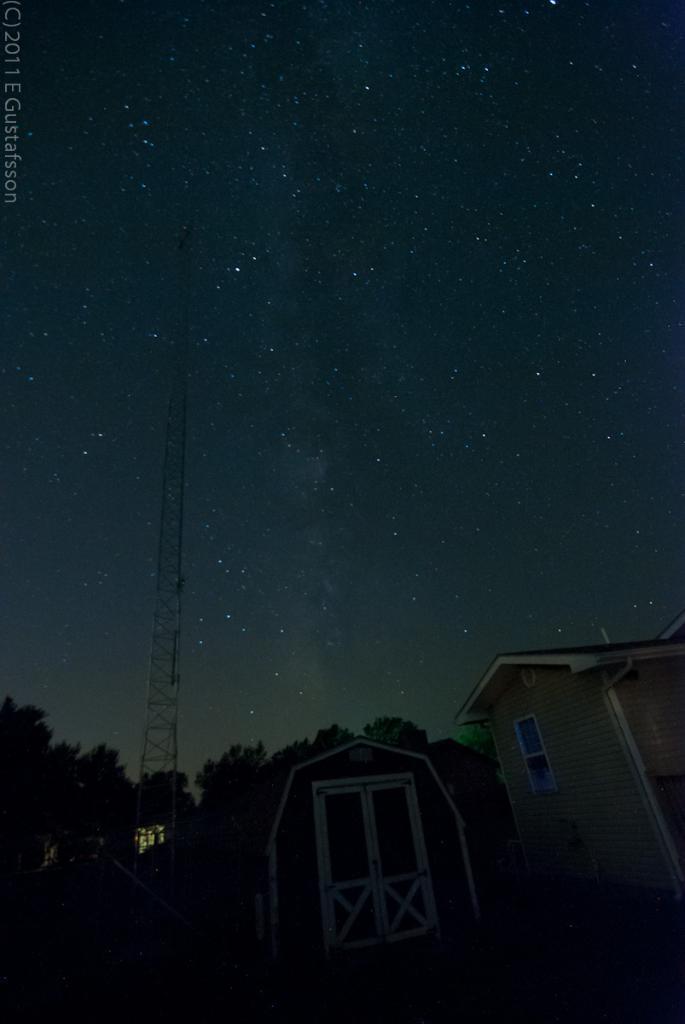In one or two sentences, can you explain what this image depicts? In this picture there are houses in the center of the image and there is a tower on the left side of the image and there are trees behind the houses and there are stars in the sky, it seems to be the picture is captured during night time. 